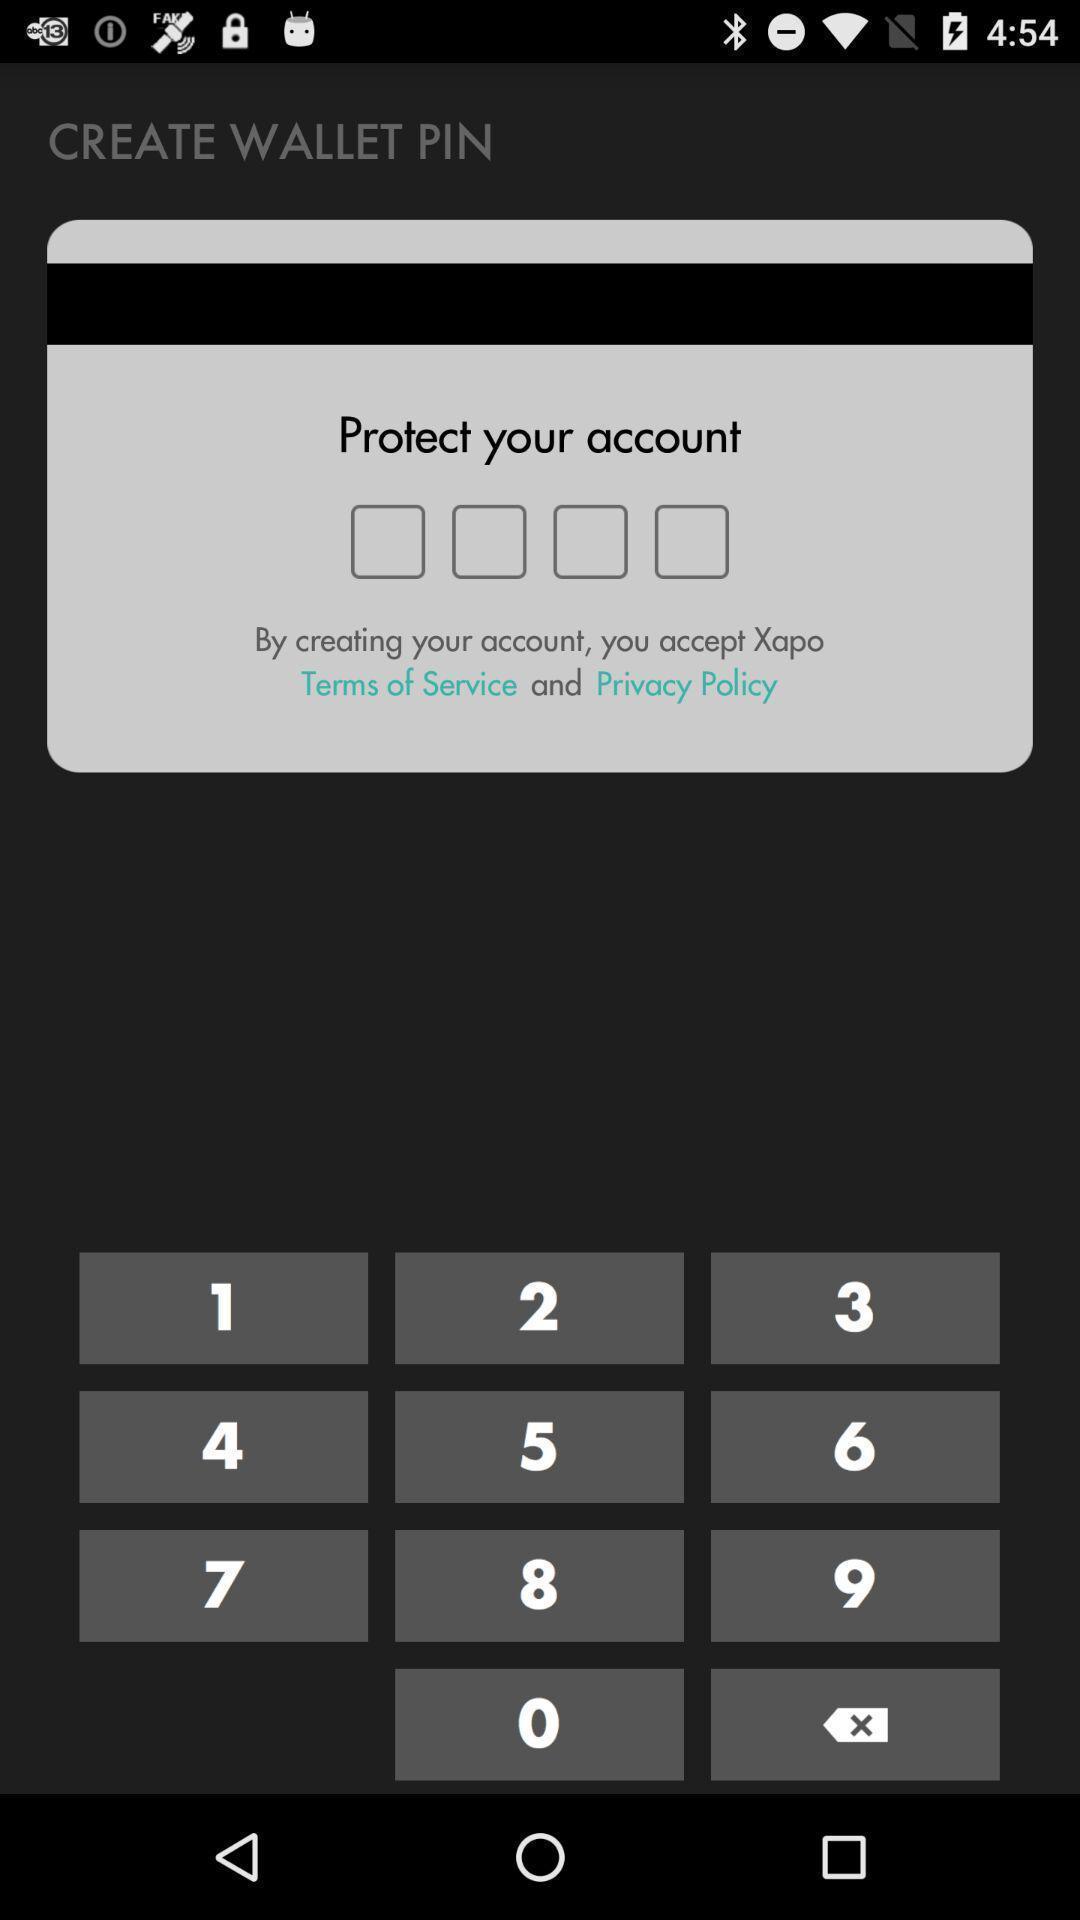Give me a narrative description of this picture. Page with keypad for entering a code. 